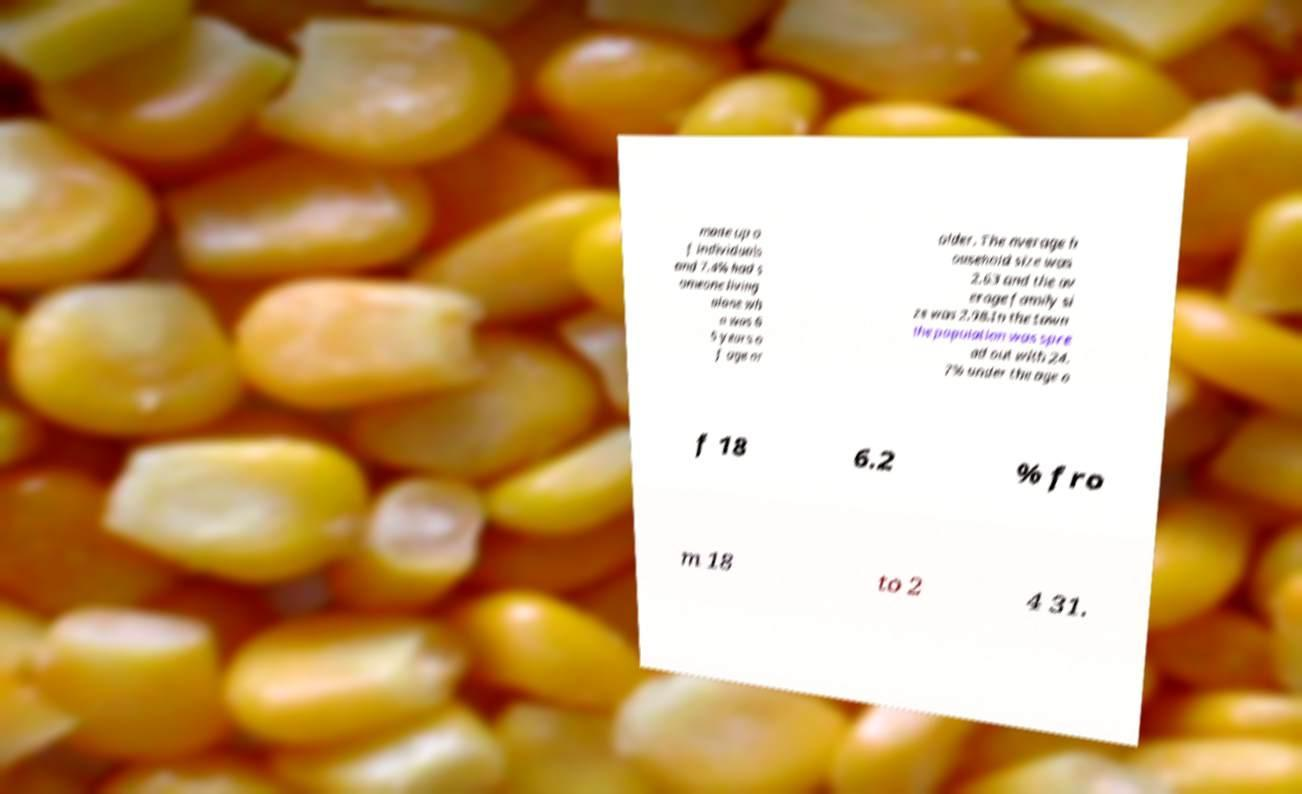Can you accurately transcribe the text from the provided image for me? made up o f individuals and 7.4% had s omeone living alone wh o was 6 5 years o f age or older. The average h ousehold size was 2.63 and the av erage family si ze was 2.98.In the town the population was spre ad out with 24. 7% under the age o f 18 6.2 % fro m 18 to 2 4 31. 